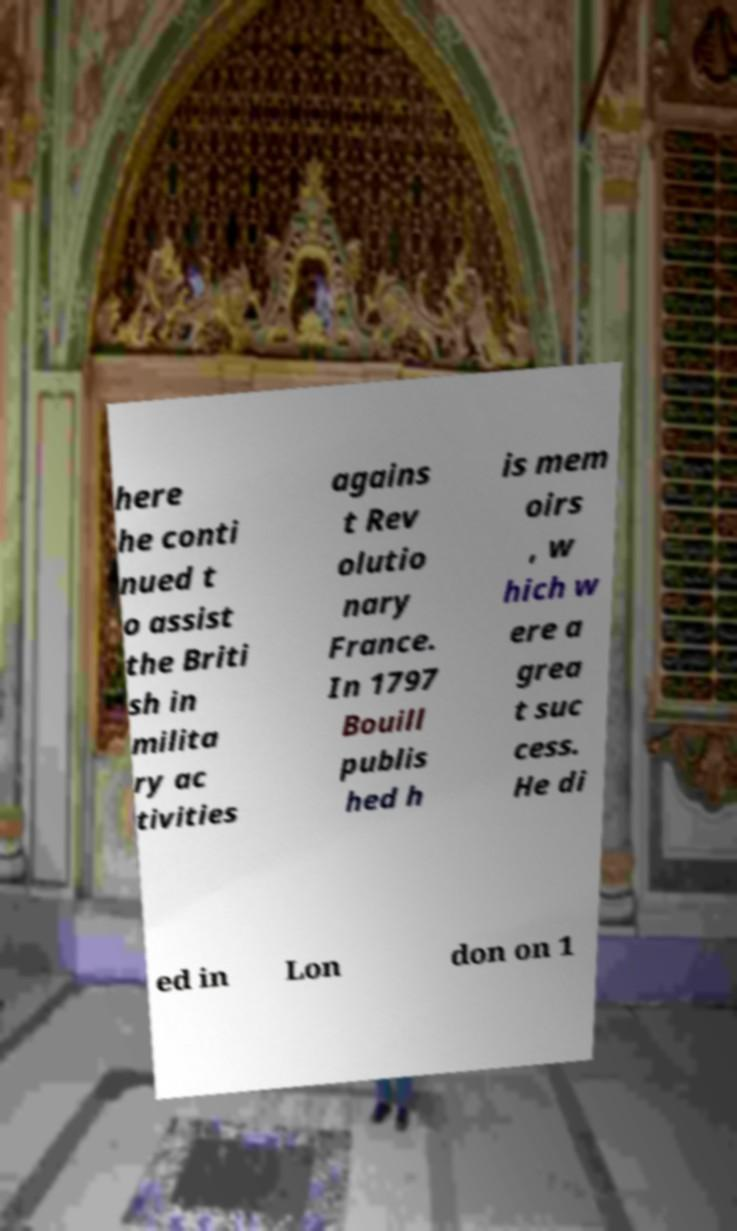Please read and relay the text visible in this image. What does it say? here he conti nued t o assist the Briti sh in milita ry ac tivities agains t Rev olutio nary France. In 1797 Bouill publis hed h is mem oirs , w hich w ere a grea t suc cess. He di ed in Lon don on 1 